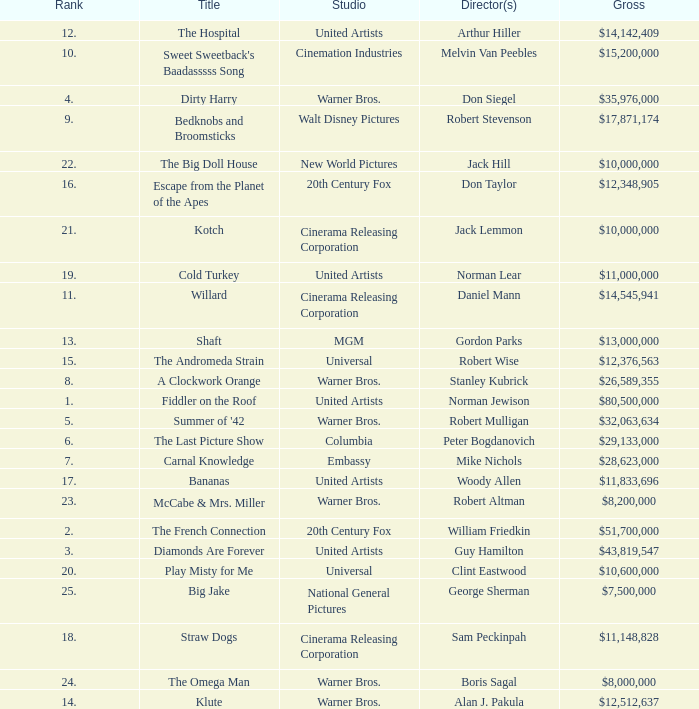What rank is the title with a gross of $26,589,355? 8.0. 